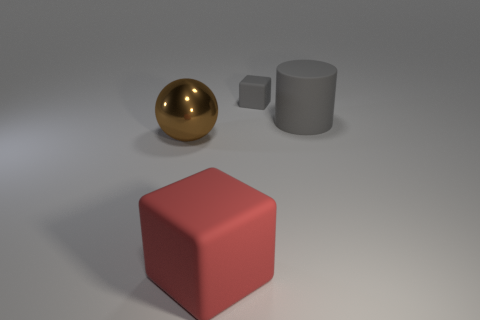Is there a rubber object that has the same color as the matte cylinder?
Offer a very short reply. Yes. The tiny thing that is the same color as the large cylinder is what shape?
Provide a succinct answer. Cube. There is a red matte thing; is its shape the same as the small gray matte object right of the red cube?
Give a very brief answer. Yes. What is the color of the thing that is both behind the brown shiny ball and in front of the tiny gray object?
Keep it short and to the point. Gray. Is there a large gray rubber thing?
Offer a very short reply. Yes. Are there an equal number of spheres to the right of the gray rubber cylinder and large cyan cubes?
Offer a very short reply. Yes. How many other things are there of the same shape as the large gray matte thing?
Ensure brevity in your answer.  0. There is a large brown object; what shape is it?
Your answer should be compact. Sphere. Is the large red thing made of the same material as the gray block?
Ensure brevity in your answer.  Yes. Are there the same number of objects in front of the gray cylinder and rubber objects that are in front of the tiny matte object?
Your answer should be compact. Yes. 